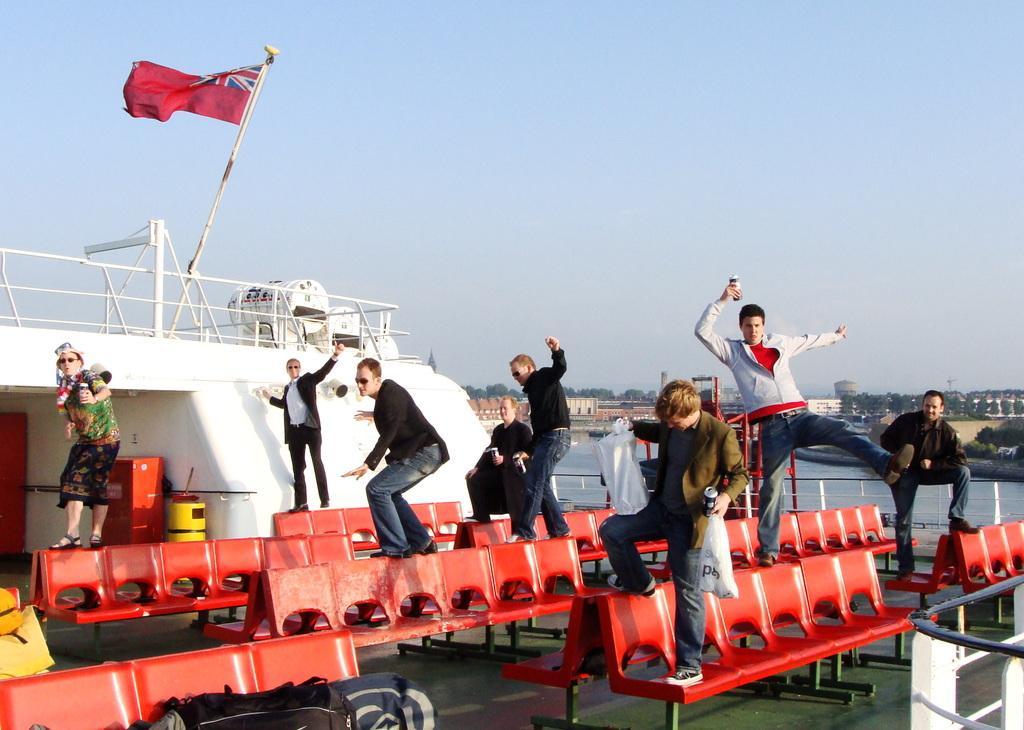Can you describe this image briefly? In this picture, we see people standing on the chairs. The man in the middle of the picture is holding a coke bottle and plastic bag in his hands. Beside them, we see an iron railing and a flag in red color. Behind them, we see water. There are trees and buildings in the background. At the top of the picture, we see the sky. 